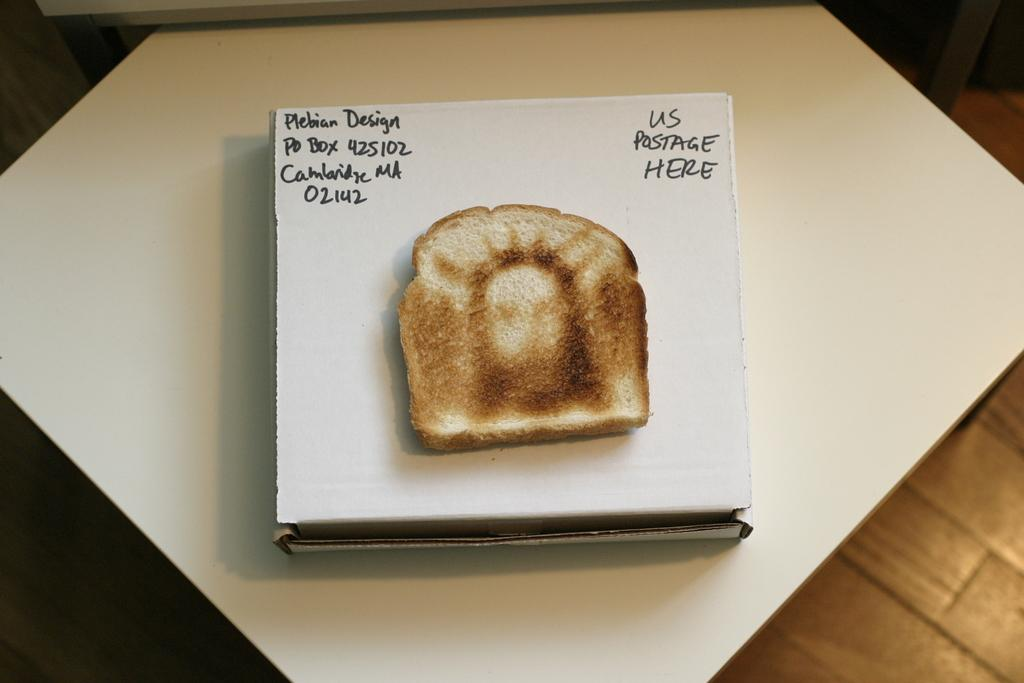What is the main subject in the foreground of the image? There is a bread piece in the foreground of the image. What is the bread piece placed on? The bread piece is on a cardboard box. Where is the cardboard box located? The cardboard box is on a white table. What type of flooring can be seen in the background of the image? There is a wooden floor in the background of the image. What type of brain is visible on the wooden floor in the image? There is no brain visible in the image; the wooden floor is the only element mentioned in the background. 